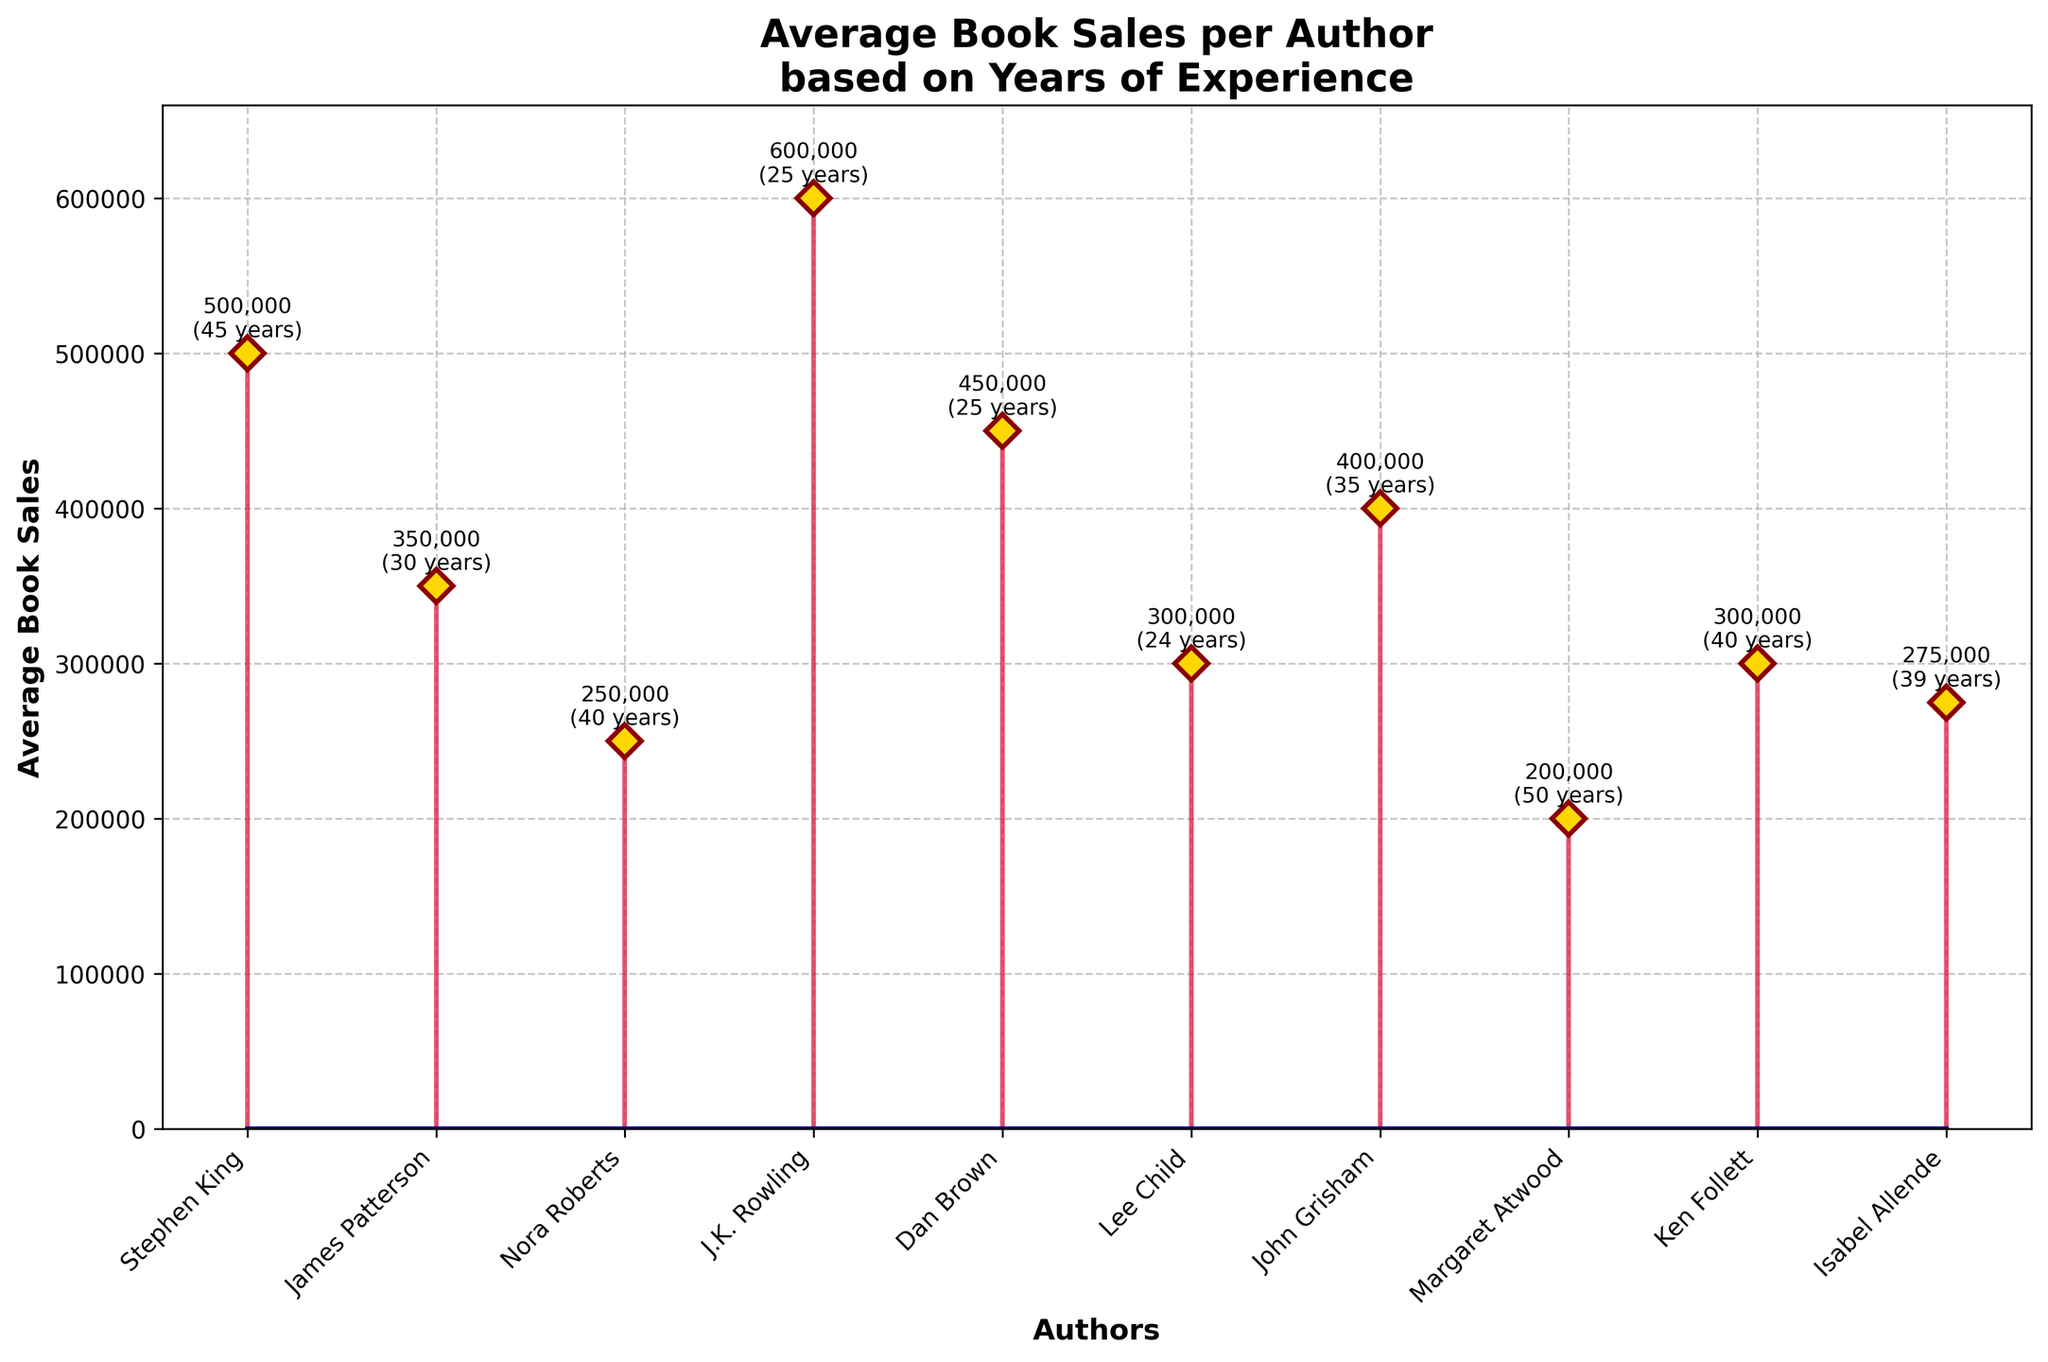Who has the highest average book sales? To find the author with the highest average book sales, look at the data points and identify the tallest stem, which corresponds to the highest numerical value. In the plot, J.K. Rowling has the highest average book sales of 600,000 copies.
Answer: J.K. Rowling What is the title of the figure? The title of the figure is usually displayed at the top of the plot, often in bold text. In this case, the title is 'Average Book Sales per Author based on Years of Experience.'
Answer: 'Average Book Sales per Author based on Years of Experience' How many authors have average book sales greater than 400,000? Identify the stems whose tips are above the 400,000 mark on the y-axis. These authors are J.K. Rowling (600,000), Stephen King (500,000), and Dan Brown (450,000).
Answer: 3 What's the average years of experience for these veteran authors? To find the average, sum the years of experience for each author and divide by the total number of authors. (45+30+40+25+25+24+35+50+40+39)/10 = 353/10 = 35.3
Answer: 35.3 Who has more average book sales: James Patterson or Dan Brown? Compare the stems for James Patterson and Dan Brown. James Patterson has an average of 350,000, while Dan Brown has 450,000.
Answer: Dan Brown Which author has the least number of years of experience, and what are their average book sales? Look for the shortest stem in terms of years of experience and check the corresponding average book sales. Lee Child has 24 years of experience and 300,000 average book sales.
Answer: Lee Child, 300,000 What is the difference in average book sales between the highest-selling author and the lowest-selling author? Find the difference between the highest and lowest average book sales. J.K. Rowling (600,000) and Margaret Atwood (200,000). (600,000 - 200,000) = 400,000.
Answer: 400,000 How does John Grisham's average book sales compare to the median average book sales of all authors? List all values: 600,000, 500,000, 450,000, 400,000, 350,000, 300,000, 300,000, 275,000, 250,000, 200,000. The median is the middle value, (300,000+300,000)/2 = 300,000. John Grisham's sales are 400,000, which is higher.
Answer: Higher Identify and list all authors with more than 30 years of experience and their respective average book sales. Authors with experience >30 years are Stephen King (500,000), John Grisham (400,000), Margaret Atwood (200,000), Ken Follett (300,000), and Isabel Allende (275,000).
Answer: Stephen King (500,000), John Grisham (400,000), Margaret Atwood (200,000), Ken Follett (300,000), Isabel Allende (275,000) Which author has the most years of experience, and what are their average book sales? Look for the longest-stemmed author and note their average book sales. Margaret Atwood has 50 years and sales of 200,000.
Answer: Margaret Atwood, 200,000 